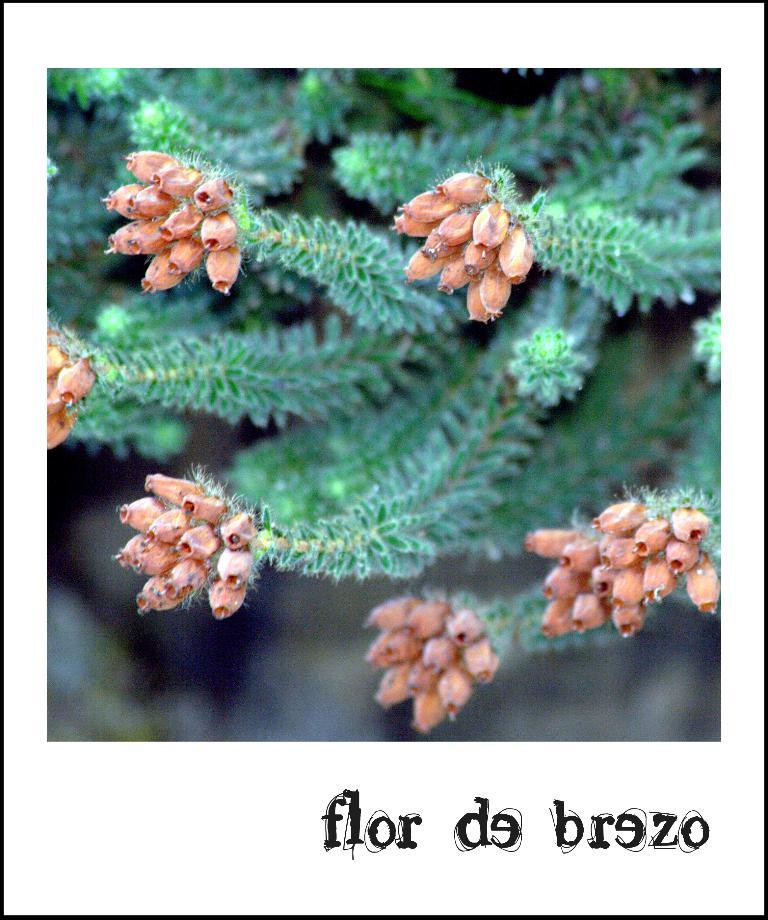What type of living organisms can be seen in the image? Plants can be seen in the image. What is written at the bottom of the image? There are words written at the bottom of the image. How many ants are crawling on the plants in the image? There are no ants visible in the image. What type of rest can be seen in the image? There is no rest or resting area depicted in the image. 